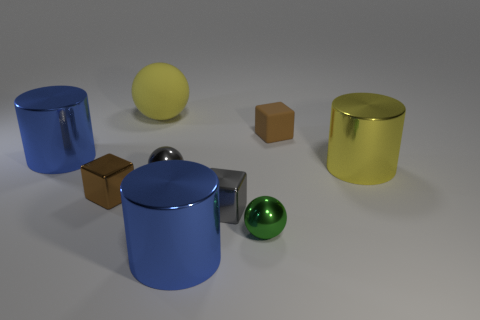Add 1 small matte blocks. How many objects exist? 10 Subtract all cubes. How many objects are left? 6 Subtract all gray rubber cylinders. Subtract all large yellow spheres. How many objects are left? 8 Add 7 cylinders. How many cylinders are left? 10 Add 2 big blue metal cylinders. How many big blue metal cylinders exist? 4 Subtract 0 green cylinders. How many objects are left? 9 